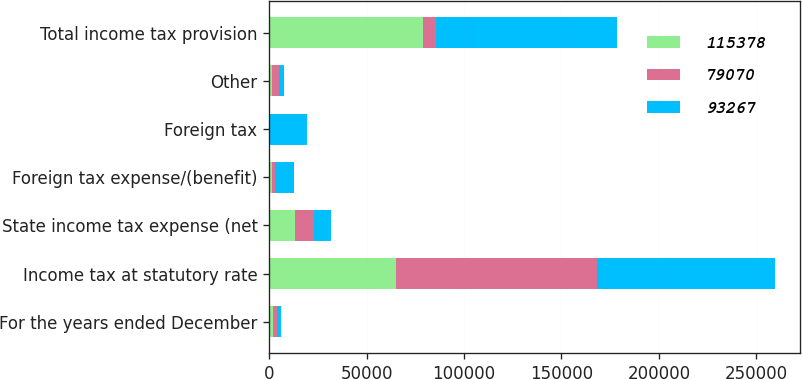<chart> <loc_0><loc_0><loc_500><loc_500><stacked_bar_chart><ecel><fcel>For the years ended December<fcel>Income tax at statutory rate<fcel>State income tax expense (net<fcel>Foreign tax expense/(benefit)<fcel>Foreign tax<fcel>Other<fcel>Total income tax provision<nl><fcel>115378<fcel>2018<fcel>65254<fcel>12984<fcel>1186<fcel>234<fcel>1353<fcel>79070<nl><fcel>79070<fcel>2017<fcel>103075<fcel>9979<fcel>1613<fcel>221<fcel>3798<fcel>6337<nl><fcel>93267<fcel>2016<fcel>91222<fcel>8876<fcel>9857<fcel>19155<fcel>2467<fcel>93267<nl></chart> 